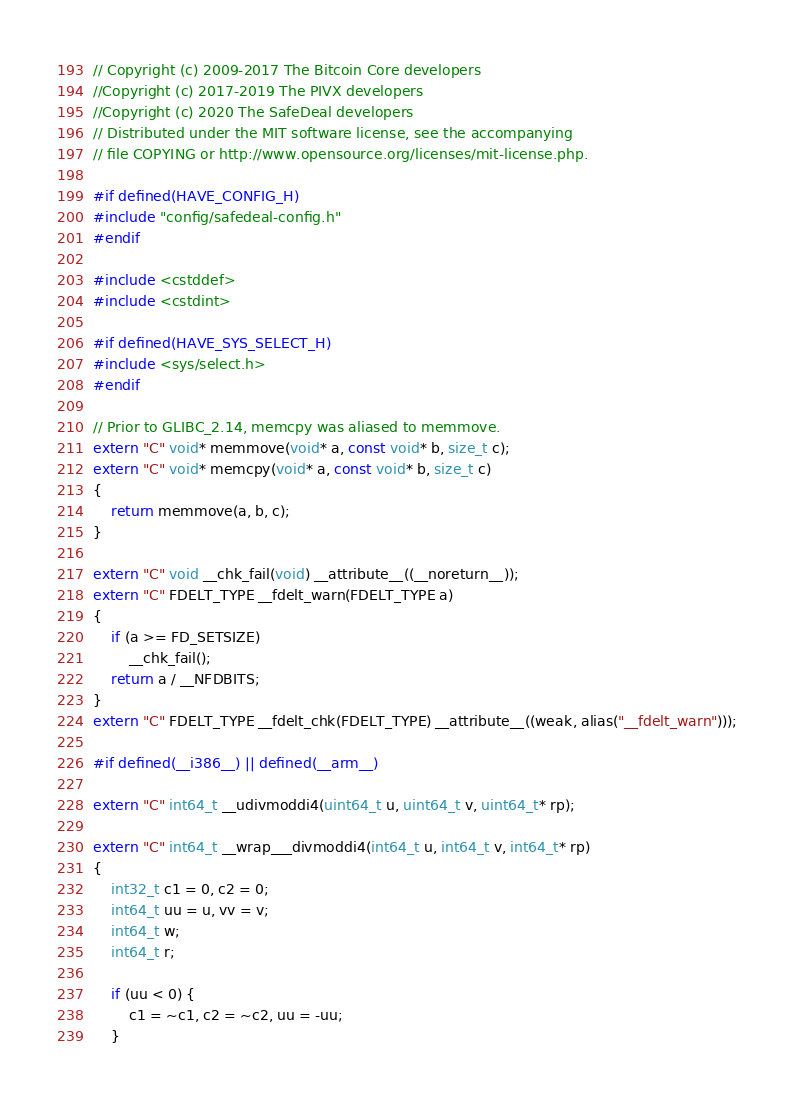Convert code to text. <code><loc_0><loc_0><loc_500><loc_500><_C++_>// Copyright (c) 2009-2017 The Bitcoin Core developers
//Copyright (c) 2017-2019 The PIVX developers
//Copyright (c) 2020 The SafeDeal developers
// Distributed under the MIT software license, see the accompanying
// file COPYING or http://www.opensource.org/licenses/mit-license.php.

#if defined(HAVE_CONFIG_H)
#include "config/safedeal-config.h"
#endif

#include <cstddef>
#include <cstdint>

#if defined(HAVE_SYS_SELECT_H)
#include <sys/select.h>
#endif

// Prior to GLIBC_2.14, memcpy was aliased to memmove.
extern "C" void* memmove(void* a, const void* b, size_t c);
extern "C" void* memcpy(void* a, const void* b, size_t c)
{
    return memmove(a, b, c);
}

extern "C" void __chk_fail(void) __attribute__((__noreturn__));
extern "C" FDELT_TYPE __fdelt_warn(FDELT_TYPE a)
{
    if (a >= FD_SETSIZE)
        __chk_fail();
    return a / __NFDBITS;
}
extern "C" FDELT_TYPE __fdelt_chk(FDELT_TYPE) __attribute__((weak, alias("__fdelt_warn")));

#if defined(__i386__) || defined(__arm__)

extern "C" int64_t __udivmoddi4(uint64_t u, uint64_t v, uint64_t* rp);

extern "C" int64_t __wrap___divmoddi4(int64_t u, int64_t v, int64_t* rp)
{
    int32_t c1 = 0, c2 = 0;
    int64_t uu = u, vv = v;
    int64_t w;
    int64_t r;

    if (uu < 0) {
        c1 = ~c1, c2 = ~c2, uu = -uu;
    }</code> 